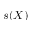<formula> <loc_0><loc_0><loc_500><loc_500>s ( X )</formula> 